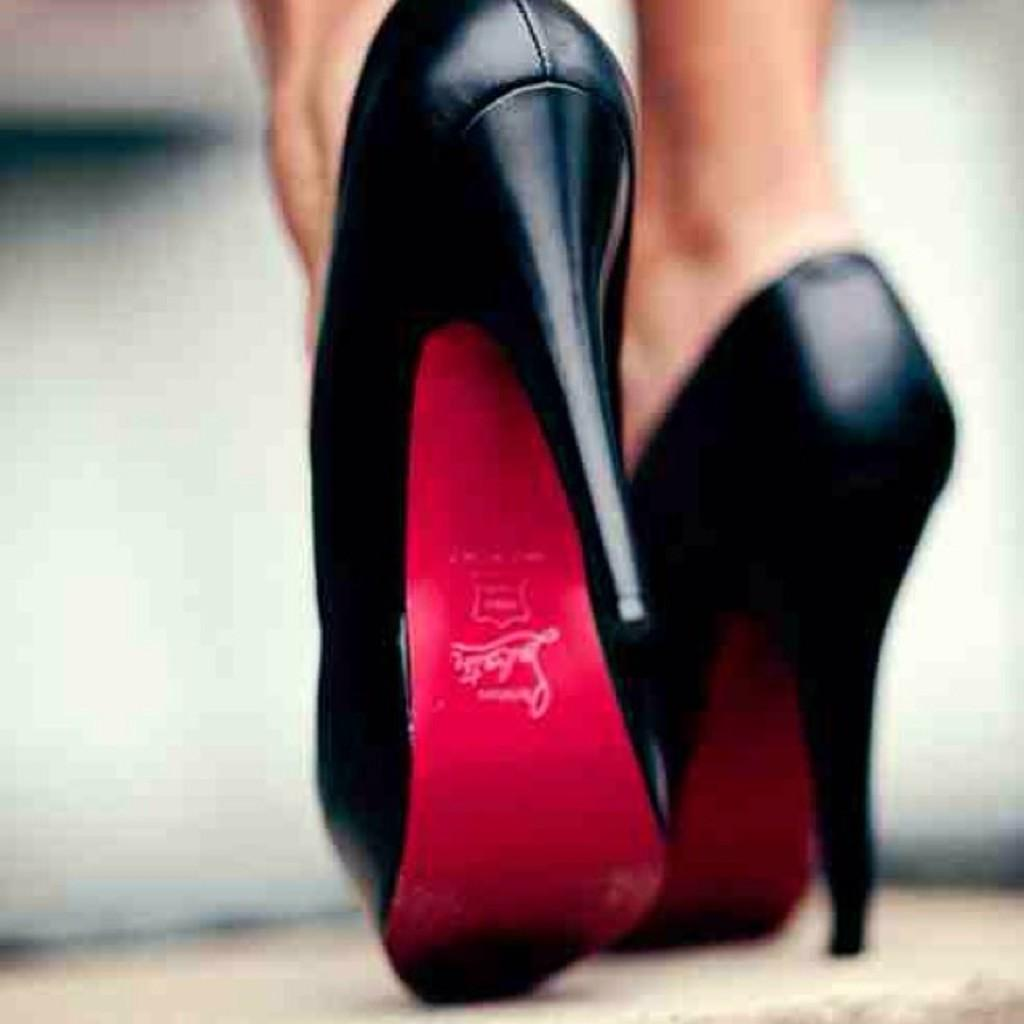What part of a person can be seen in the image? There are legs of a person in the image. What type of footwear is visible in the image? Footwear is visible in the image. Can you describe the background of the image? The background of the image is blurred. What time of day is it in the image? The time of day cannot be determined from the image, as there is no information about lighting or shadows to suggest whether it is day or night. 